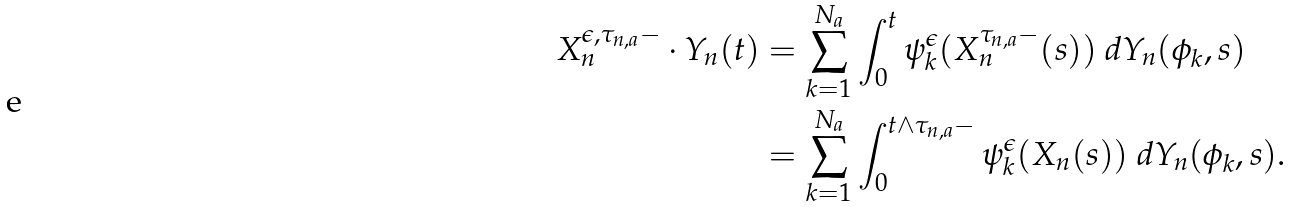<formula> <loc_0><loc_0><loc_500><loc_500>X _ { n } ^ { \epsilon , \tau _ { n , a } - } \cdot Y _ { n } ( t ) & = \sum _ { k = 1 } ^ { N _ { a } } \int _ { 0 } ^ { t } \psi _ { k } ^ { \epsilon } ( X _ { n } ^ { \tau _ { n , a } - } ( s ) ) \ d Y _ { n } ( \phi _ { k } , s ) \\ & = \sum _ { k = 1 } ^ { N _ { a } } \int _ { 0 } ^ { t \wedge \tau _ { n , a } - } \psi _ { k } ^ { \epsilon } ( X _ { n } ( s ) ) \ d Y _ { n } ( \phi _ { k } , s ) .</formula> 